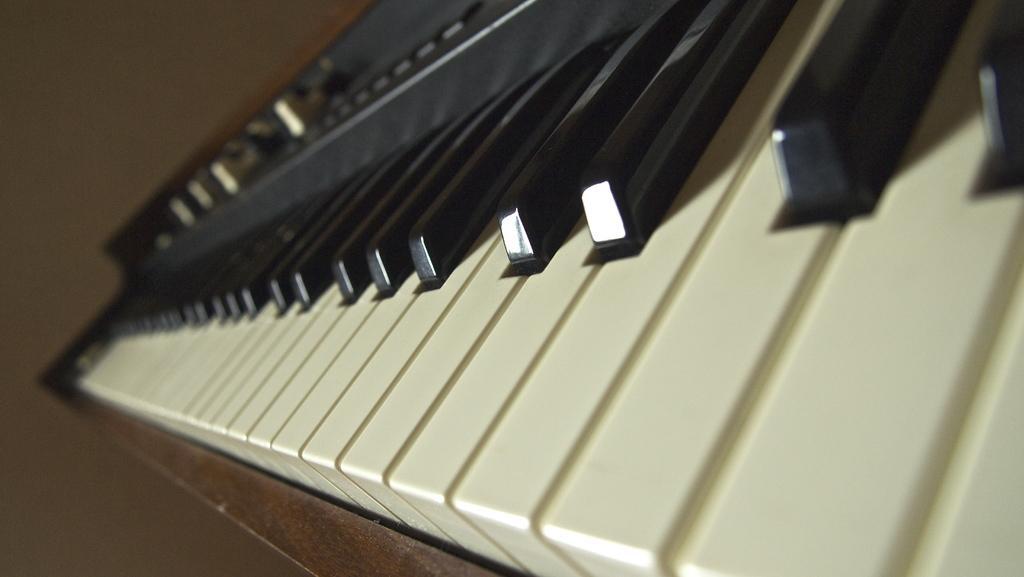In one or two sentences, can you explain what this image depicts? In this picture there is a piano. We can see white and black buttons on a piano. On the left there is a wall. 